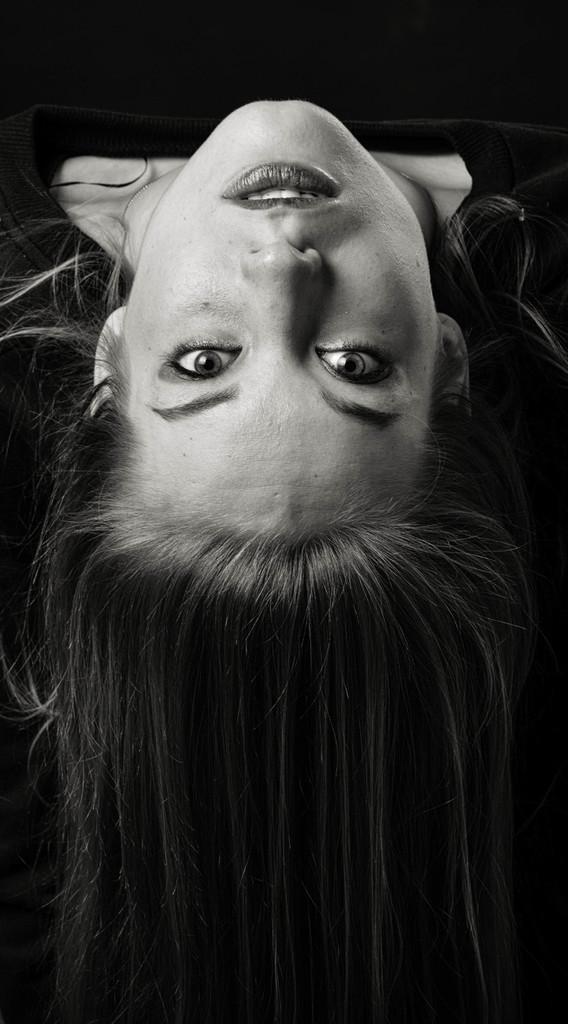Can you describe this image briefly? In this picture we can see a woman. Background is black in color. 